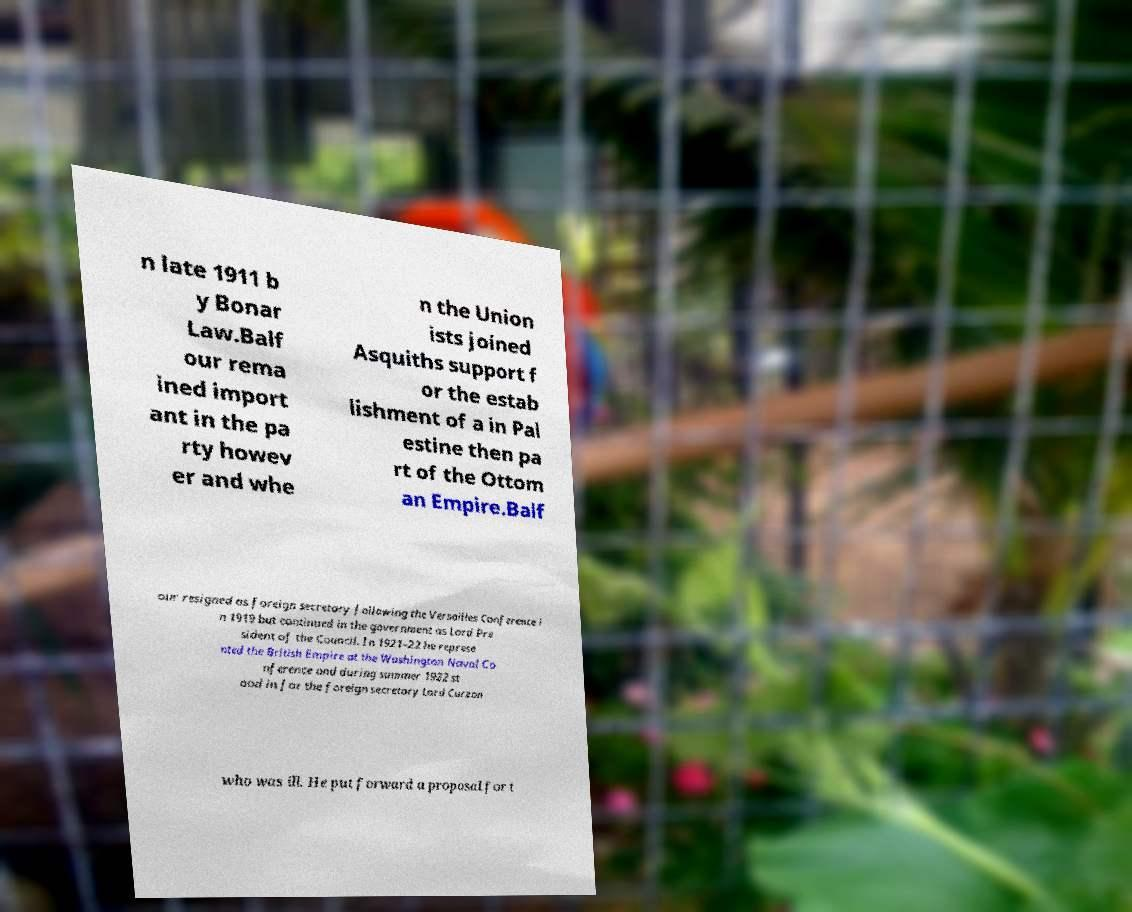Can you accurately transcribe the text from the provided image for me? n late 1911 b y Bonar Law.Balf our rema ined import ant in the pa rty howev er and whe n the Union ists joined Asquiths support f or the estab lishment of a in Pal estine then pa rt of the Ottom an Empire.Balf our resigned as foreign secretary following the Versailles Conference i n 1919 but continued in the government as Lord Pre sident of the Council. In 1921–22 he represe nted the British Empire at the Washington Naval Co nference and during summer 1922 st ood in for the foreign secretary Lord Curzon who was ill. He put forward a proposal for t 